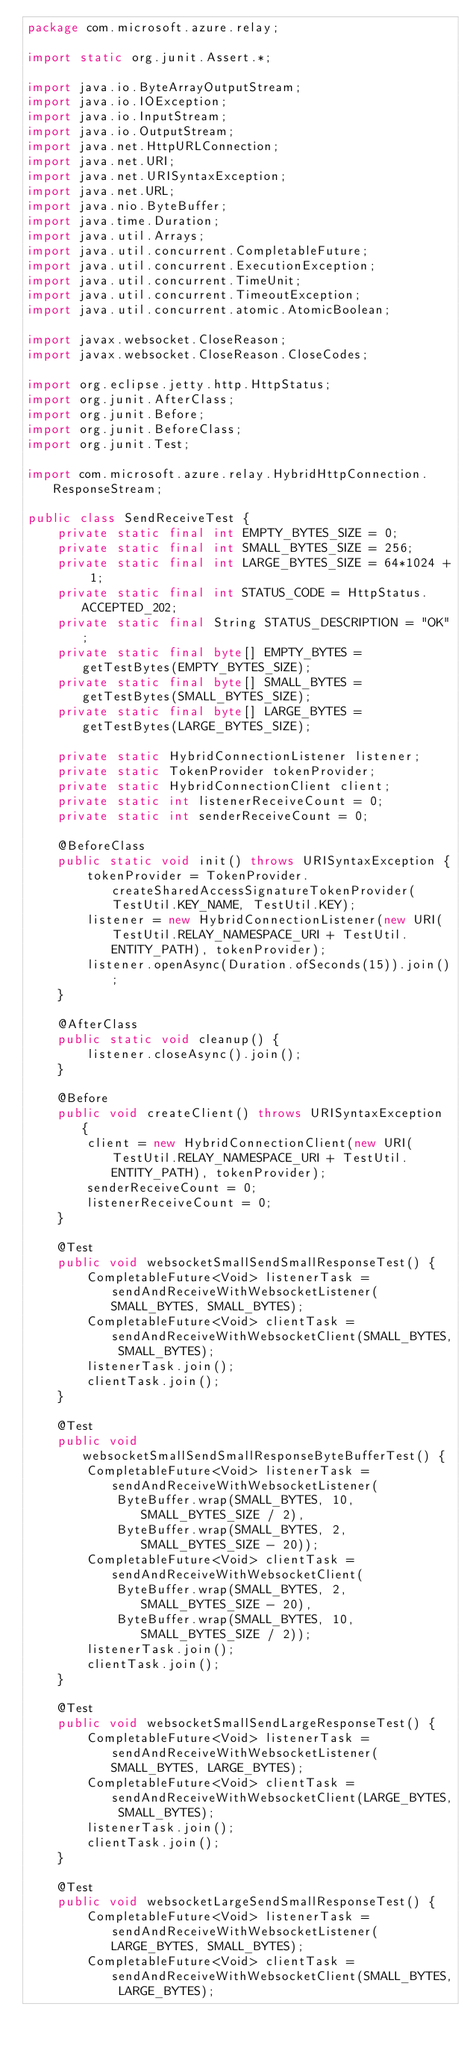Convert code to text. <code><loc_0><loc_0><loc_500><loc_500><_Java_>package com.microsoft.azure.relay;

import static org.junit.Assert.*;

import java.io.ByteArrayOutputStream;
import java.io.IOException;
import java.io.InputStream;
import java.io.OutputStream;
import java.net.HttpURLConnection;
import java.net.URI;
import java.net.URISyntaxException;
import java.net.URL;
import java.nio.ByteBuffer;
import java.time.Duration;
import java.util.Arrays;
import java.util.concurrent.CompletableFuture;
import java.util.concurrent.ExecutionException;
import java.util.concurrent.TimeUnit;
import java.util.concurrent.TimeoutException;
import java.util.concurrent.atomic.AtomicBoolean;

import javax.websocket.CloseReason;
import javax.websocket.CloseReason.CloseCodes;

import org.eclipse.jetty.http.HttpStatus;
import org.junit.AfterClass;
import org.junit.Before;
import org.junit.BeforeClass;
import org.junit.Test;

import com.microsoft.azure.relay.HybridHttpConnection.ResponseStream;

public class SendReceiveTest {
	private static final int EMPTY_BYTES_SIZE = 0;
	private static final int SMALL_BYTES_SIZE = 256;
	private static final int LARGE_BYTES_SIZE = 64*1024 + 1;
	private static final int STATUS_CODE = HttpStatus.ACCEPTED_202;
	private static final String STATUS_DESCRIPTION = "OK";
	private static final byte[] EMPTY_BYTES = getTestBytes(EMPTY_BYTES_SIZE);
	private static final byte[] SMALL_BYTES = getTestBytes(SMALL_BYTES_SIZE);
	private static final byte[] LARGE_BYTES = getTestBytes(LARGE_BYTES_SIZE);
	
	private static HybridConnectionListener listener;
	private static TokenProvider tokenProvider;
	private static HybridConnectionClient client;
	private static int listenerReceiveCount = 0;
	private static int senderReceiveCount = 0;
	
	@BeforeClass
	public static void init() throws URISyntaxException {
		tokenProvider = TokenProvider.createSharedAccessSignatureTokenProvider(TestUtil.KEY_NAME, TestUtil.KEY);
		listener = new HybridConnectionListener(new URI(TestUtil.RELAY_NAMESPACE_URI + TestUtil.ENTITY_PATH), tokenProvider);
		listener.openAsync(Duration.ofSeconds(15)).join();
	}
	
	@AfterClass
	public static void cleanup() {
		listener.closeAsync().join();
	}
	
	@Before
	public void createClient() throws URISyntaxException {
		client = new HybridConnectionClient(new URI(TestUtil.RELAY_NAMESPACE_URI + TestUtil.ENTITY_PATH), tokenProvider);
		senderReceiveCount = 0;
		listenerReceiveCount = 0;
	}
	
	@Test
	public void websocketSmallSendSmallResponseTest() {
		CompletableFuture<Void> listenerTask = sendAndReceiveWithWebsocketListener(SMALL_BYTES, SMALL_BYTES);
		CompletableFuture<Void> clientTask = sendAndReceiveWithWebsocketClient(SMALL_BYTES, SMALL_BYTES);
		listenerTask.join();
		clientTask.join();
	}

	@Test
	public void websocketSmallSendSmallResponseByteBufferTest() {
		CompletableFuture<Void> listenerTask = sendAndReceiveWithWebsocketListener(
			ByteBuffer.wrap(SMALL_BYTES, 10, SMALL_BYTES_SIZE / 2),
			ByteBuffer.wrap(SMALL_BYTES, 2, SMALL_BYTES_SIZE - 20));
		CompletableFuture<Void> clientTask = sendAndReceiveWithWebsocketClient(
			ByteBuffer.wrap(SMALL_BYTES, 2, SMALL_BYTES_SIZE - 20),
			ByteBuffer.wrap(SMALL_BYTES, 10, SMALL_BYTES_SIZE / 2));
		listenerTask.join();
		clientTask.join();
	}
	
	@Test
	public void websocketSmallSendLargeResponseTest() {
		CompletableFuture<Void> listenerTask = sendAndReceiveWithWebsocketListener(SMALL_BYTES, LARGE_BYTES);
		CompletableFuture<Void> clientTask = sendAndReceiveWithWebsocketClient(LARGE_BYTES, SMALL_BYTES);
		listenerTask.join();
		clientTask.join();
	}
	
	@Test
	public void websocketLargeSendSmallResponseTest() {
		CompletableFuture<Void> listenerTask = sendAndReceiveWithWebsocketListener(LARGE_BYTES, SMALL_BYTES);
		CompletableFuture<Void> clientTask = sendAndReceiveWithWebsocketClient(SMALL_BYTES, LARGE_BYTES);</code> 